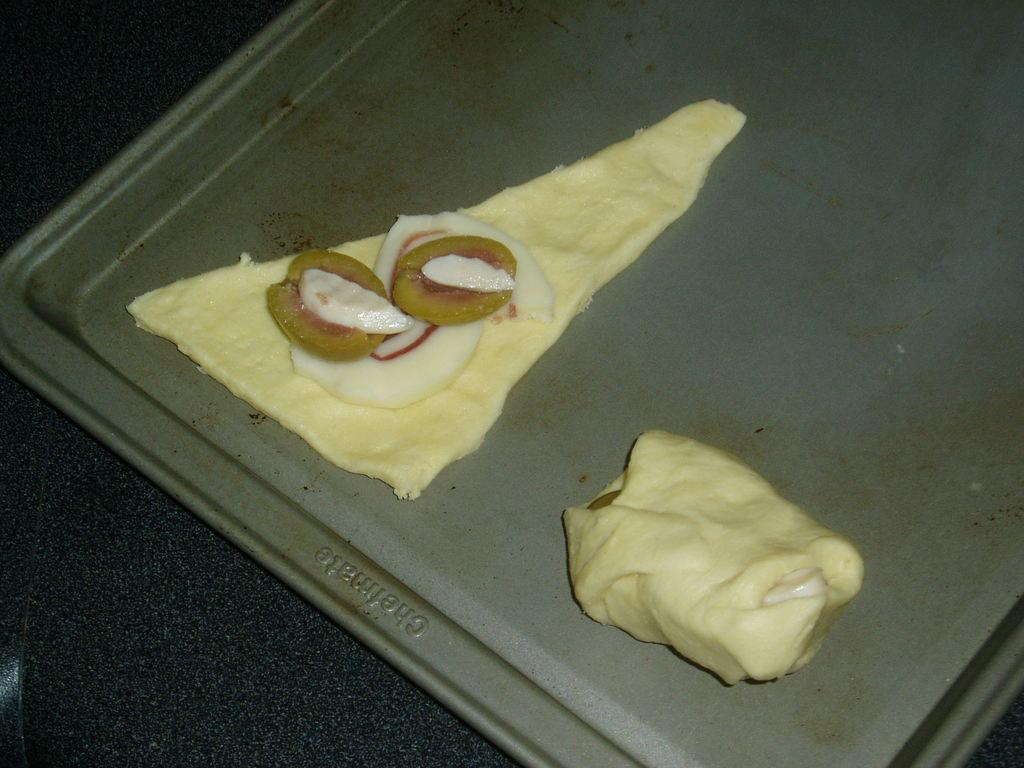What is present in the image related to food? There is food in the image. How is the food arranged or contained? The food is in a tray. Where is the tray with food located? The tray is on a table. Who is the servant attending to in the image? There is no servant present in the image. 